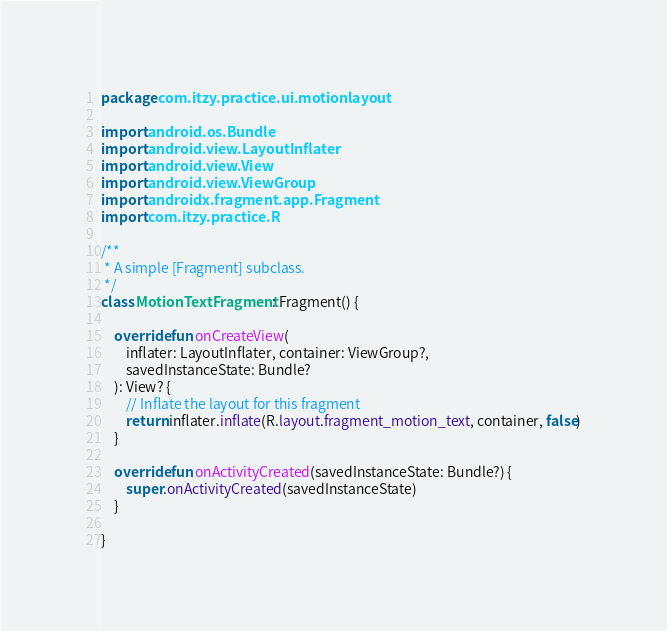<code> <loc_0><loc_0><loc_500><loc_500><_Kotlin_>package com.itzy.practice.ui.motionlayout

import android.os.Bundle
import android.view.LayoutInflater
import android.view.View
import android.view.ViewGroup
import androidx.fragment.app.Fragment
import com.itzy.practice.R

/**
 * A simple [Fragment] subclass.
 */
class MotionTextFragment : Fragment() {

    override fun onCreateView(
        inflater: LayoutInflater, container: ViewGroup?,
        savedInstanceState: Bundle?
    ): View? {
        // Inflate the layout for this fragment
        return inflater.inflate(R.layout.fragment_motion_text, container, false)
    }

    override fun onActivityCreated(savedInstanceState: Bundle?) {
        super.onActivityCreated(savedInstanceState)
    }

}
</code> 